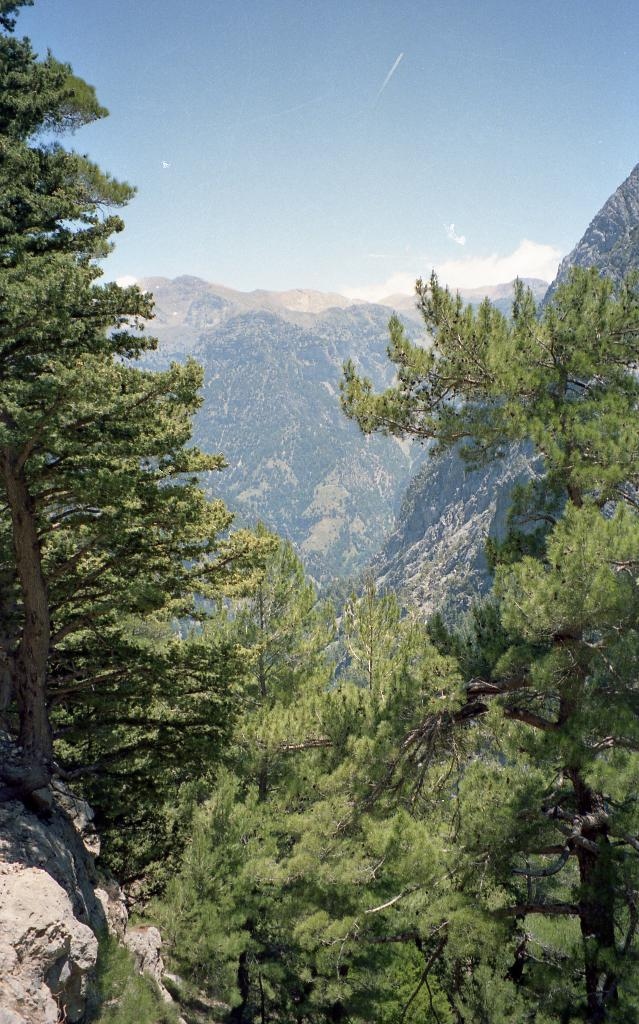What type of natural features can be seen in the image? There are trees and mountains in the image. What is visible in the background of the image? The sky is visible in the background of the image. What can be observed in the sky? Clouds are present in the sky. What type of flowers can be seen growing near the crib in the image? There is no crib or flowers present in the image; it features trees, mountains, and a sky with clouds. 